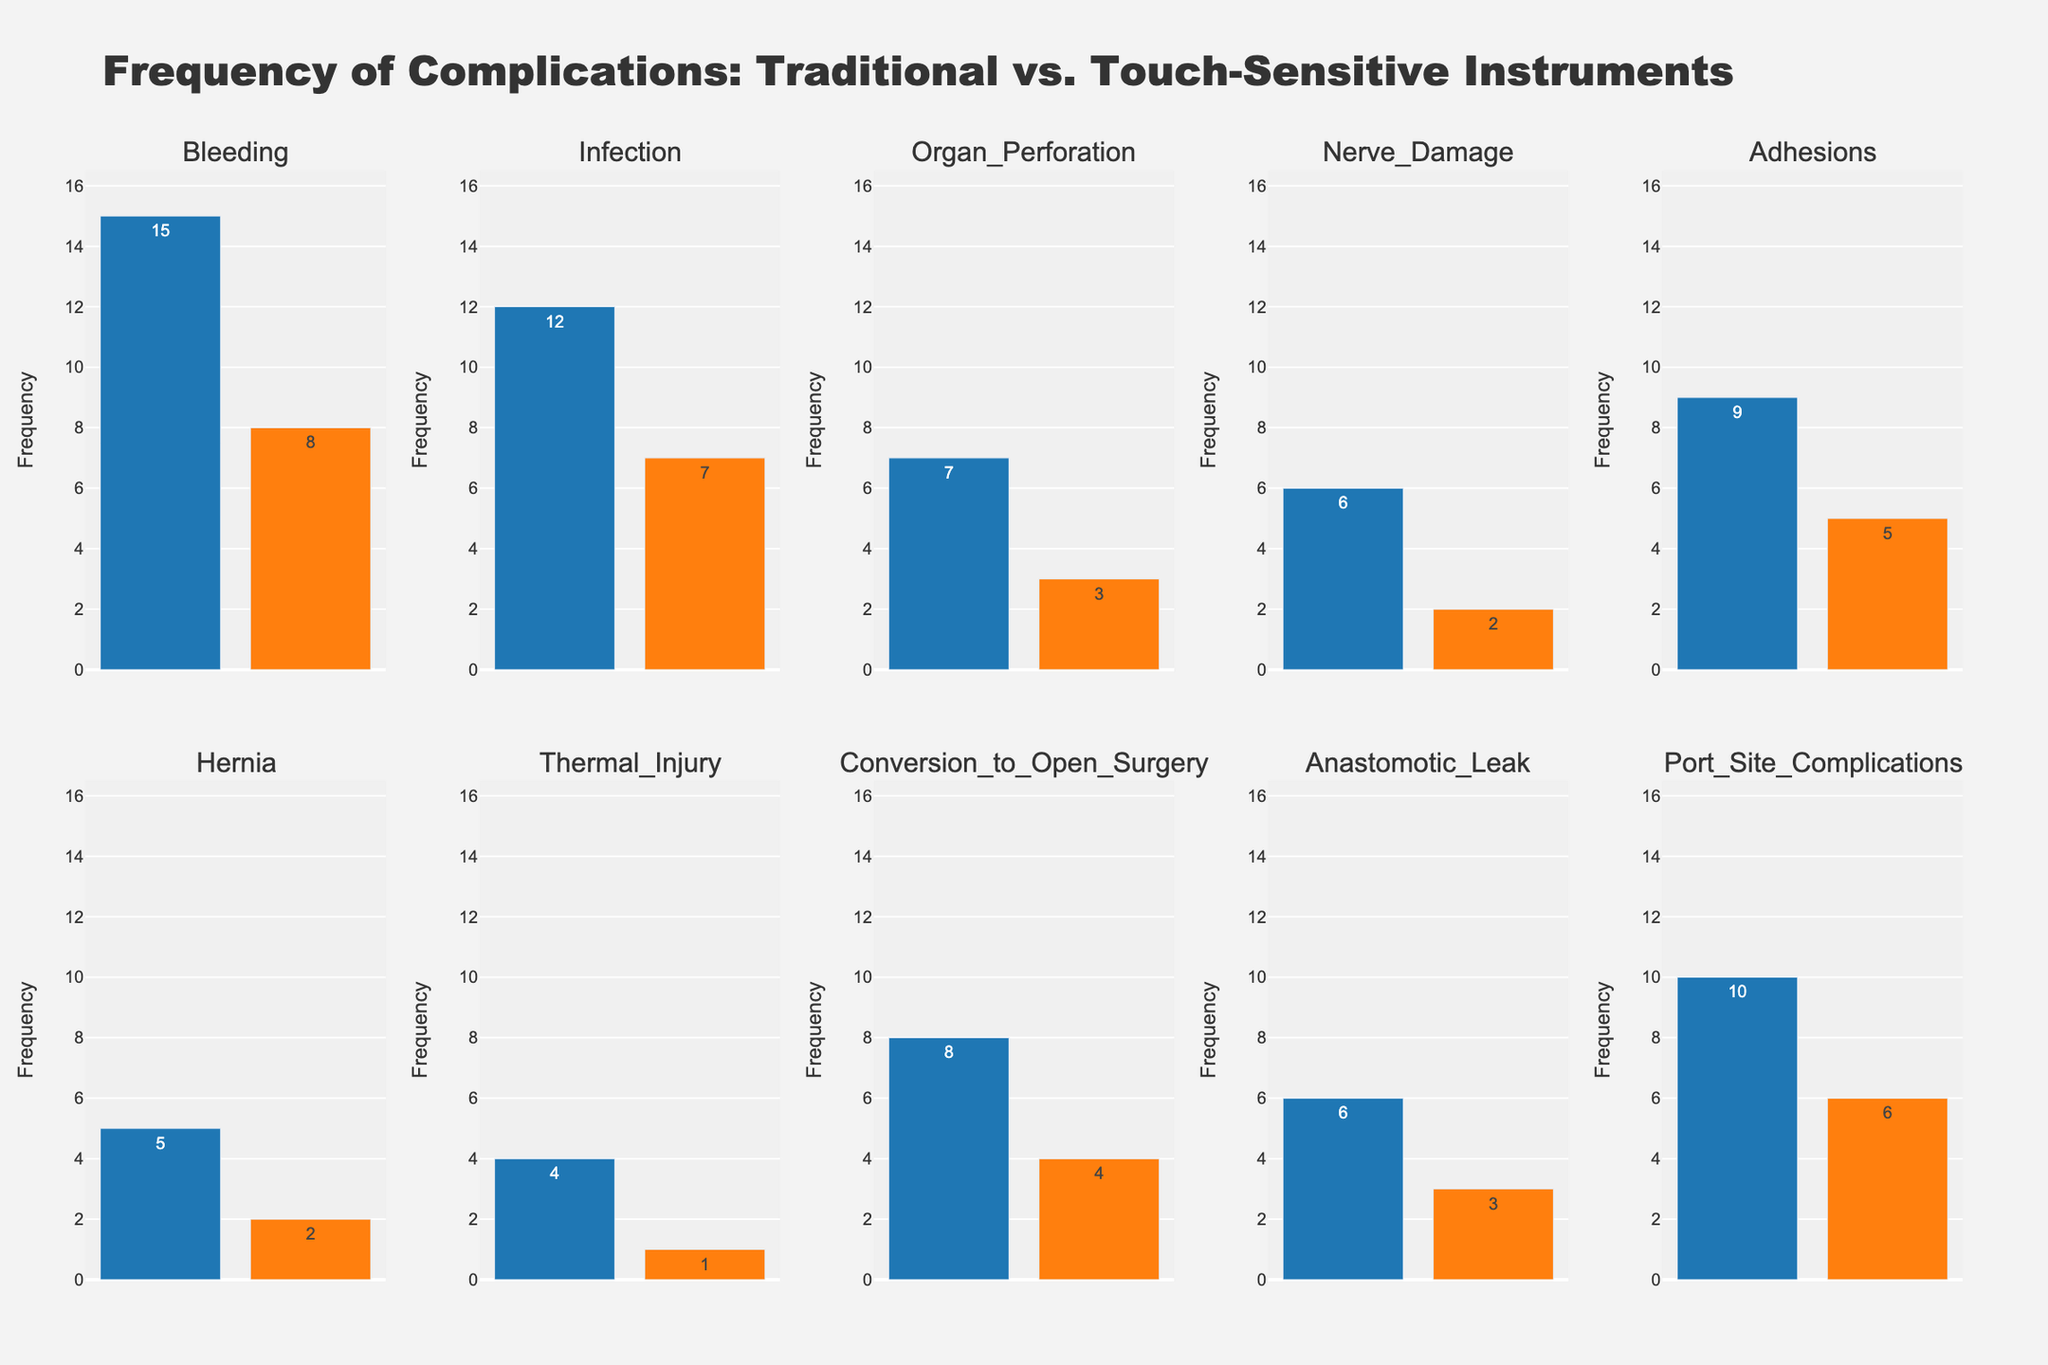What is the title of the plot? The title typically appears at the top and is centered, describing the general content of the figure. In this case, it is visible at the top of the figure and reads "Frequency of Complications: Traditional vs. Touch-Sensitive Instruments".
Answer: Frequency of Complications: Traditional vs. Touch-Sensitive Instruments Which complication shows the highest frequency for traditional instruments? To find the highest frequency, examine each subplot and look for the tallest bar representing traditional instruments. The bleaching complication has the tallest bar when using traditional instruments, indicating it has the highest frequency.
Answer: Bleeding How many complications have a lower frequency with touch-sensitive instruments compared to traditional instruments? Compare the height of the bars for each complication. Count each subplot where the bar representing touch-sensitive instruments is smaller than the bar for traditional instruments.
Answer: 10 What is the total frequency of "Infection" complications for both types of instruments? Sum the frequencies of "Infection" for traditional and touch-sensitive instruments. The values are 12 and 7, respectively. Therefore, the total frequency is 12 + 7 = 19.
Answer: 19 Which type of instrument shows a lower frequency for "Nerve Damage" complications? Compare the bars for "Nerve Damage" in both subplots. The frequency for traditional instruments is 6, while for touch-sensitive instruments, it is 2. Thus, the touch-sensitive instruments have a lower frequency.
Answer: Touch-sensitive instruments What is the average frequency of "Conversion to Open Surgery" complications? Add the frequencies of "Conversion to Open Surgery" complications for both types of instruments and divide by 2. The values are 8 (traditional) and 4 (touch-sensitive). Therefore, the average frequency is (8 + 4) / 2 = 6.
Answer: 6 Which complication has the same frequency difference between traditional and touch-sensitive instruments as "Adhesions"? First, calculate the frequency difference for "Adhesions", which is 9 - 5 = 4. Then, check other complications to find a difference of 4. "Conversion to Open Surgery" also has a difference of 4 (8 - 4 = 4).
Answer: Conversion to Open Surgery For the complication "Hernia," how much more common is the frequency with traditional instruments compared to touch-sensitive instruments? Subtract the frequency of touch-sensitive instruments from that of traditional instruments for "Hernia". The values are 5 (traditional) and 2 (touch-sensitive), so the difference is 5 - 2 = 3.
Answer: 3 How does the frequency of "Anastomotic Leak" complications with touch-sensitive instruments compare to "Organ Perforation" complications with touch-sensitive instruments? Compare the heights of the bars for these complications in their respective subplots. Both have a frequency of 3 for touch-sensitive instruments.
Answer: Equal 